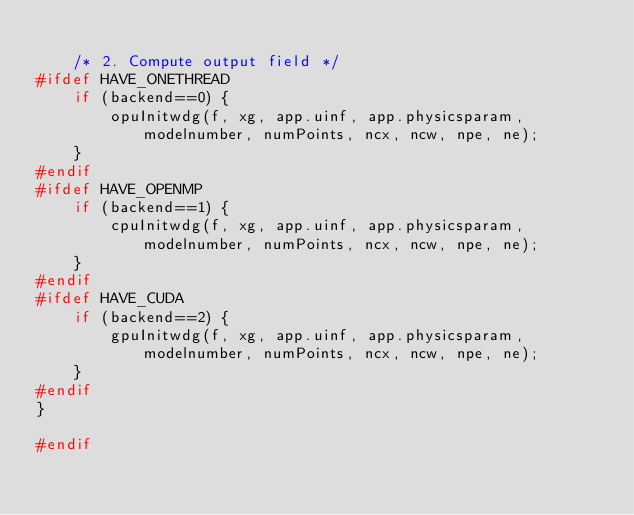Convert code to text. <code><loc_0><loc_0><loc_500><loc_500><_C++_>    
    /* 2. Compute output field */
#ifdef HAVE_ONETHREAD        
    if (backend==0) {
        opuInitwdg(f, xg, app.uinf, app.physicsparam, modelnumber, numPoints, ncx, ncw, npe, ne);                
    }
#endif              
#ifdef HAVE_OPENMP        
    if (backend==1) {
        cpuInitwdg(f, xg, app.uinf, app.physicsparam, modelnumber, numPoints, ncx, ncw, npe, ne);             
    }    
#endif            
#ifdef HAVE_CUDA             
    if (backend==2) {
        gpuInitwdg(f, xg, app.uinf, app.physicsparam, modelnumber, numPoints, ncx, ncw, npe, ne);             
    }
#endif    
}

#endif
</code> 